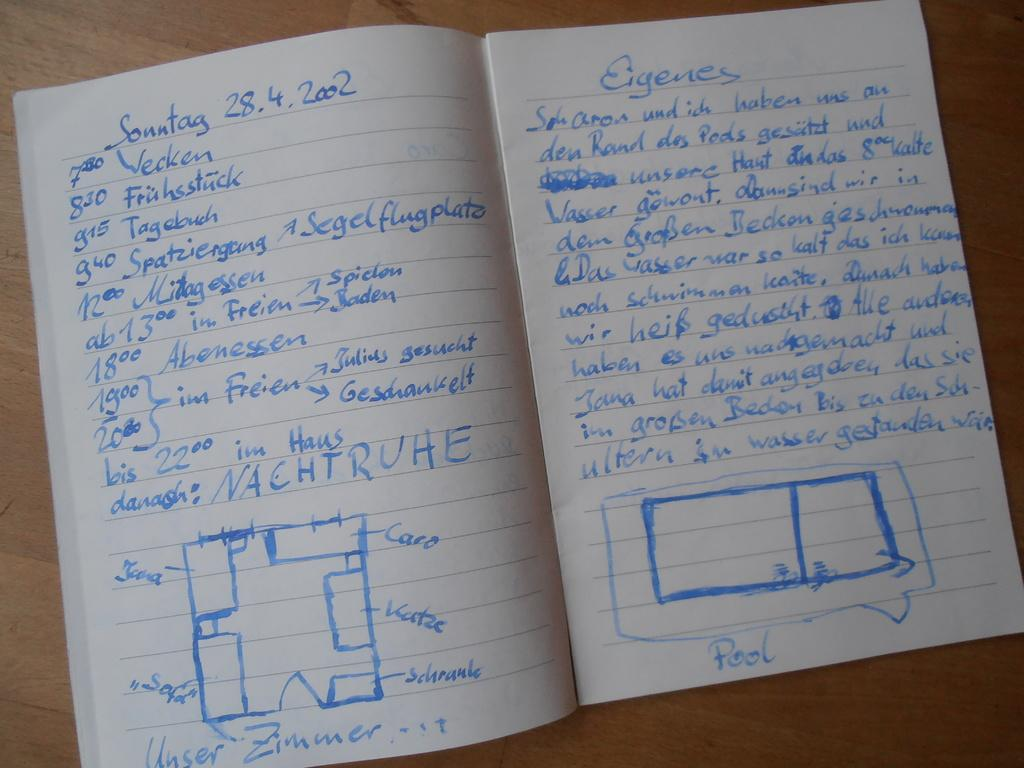<image>
Summarize the visual content of the image. Open notebook showing pages full of blue text with heading Sonntag 28.4.2002 